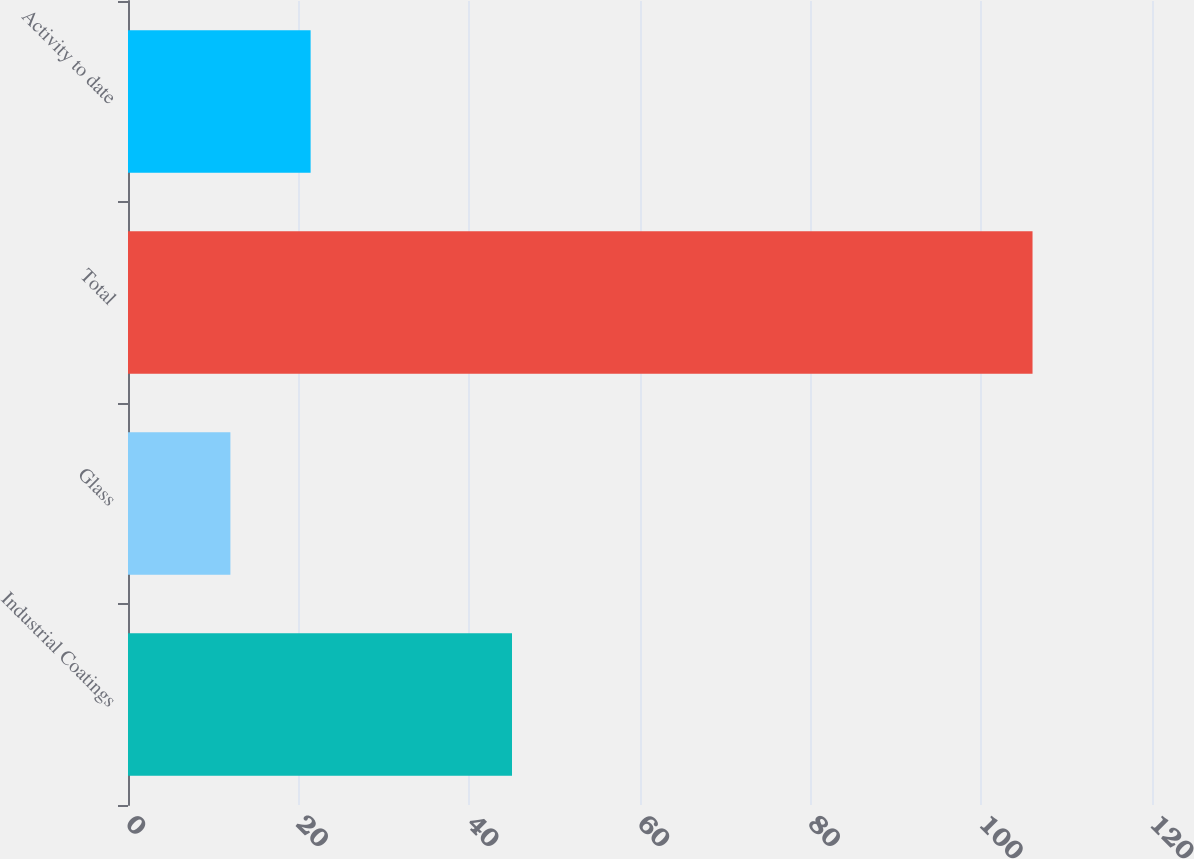<chart> <loc_0><loc_0><loc_500><loc_500><bar_chart><fcel>Industrial Coatings<fcel>Glass<fcel>Total<fcel>Activity to date<nl><fcel>45<fcel>12<fcel>106<fcel>21.4<nl></chart> 